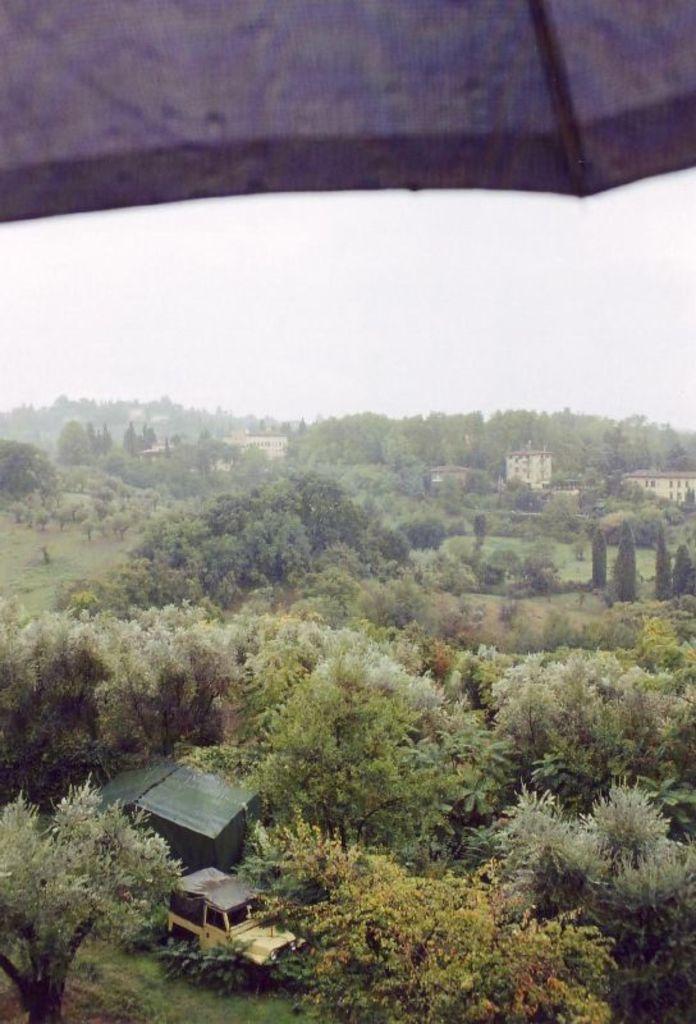Could you give a brief overview of what you see in this image? In the picture we can see trees, vehicle and in the background of the picture there are some houses and clear sky. 